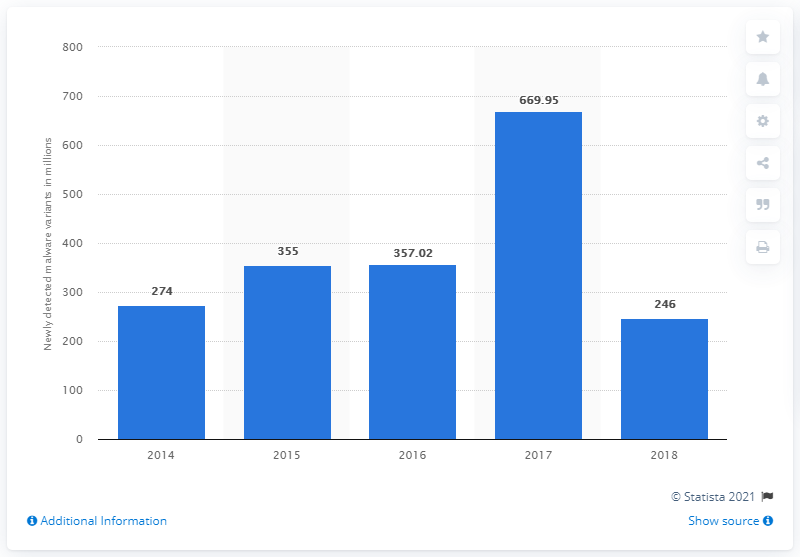Specify some key components in this picture. In 2017, there were approximately 669.95 malware variants. A total of 246 new variants of malware were observed in the most recent period. 